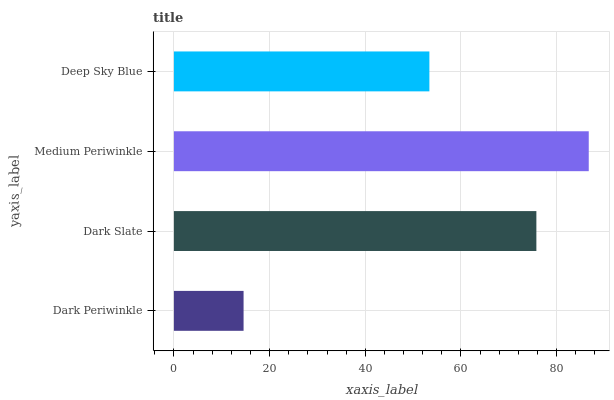Is Dark Periwinkle the minimum?
Answer yes or no. Yes. Is Medium Periwinkle the maximum?
Answer yes or no. Yes. Is Dark Slate the minimum?
Answer yes or no. No. Is Dark Slate the maximum?
Answer yes or no. No. Is Dark Slate greater than Dark Periwinkle?
Answer yes or no. Yes. Is Dark Periwinkle less than Dark Slate?
Answer yes or no. Yes. Is Dark Periwinkle greater than Dark Slate?
Answer yes or no. No. Is Dark Slate less than Dark Periwinkle?
Answer yes or no. No. Is Dark Slate the high median?
Answer yes or no. Yes. Is Deep Sky Blue the low median?
Answer yes or no. Yes. Is Medium Periwinkle the high median?
Answer yes or no. No. Is Medium Periwinkle the low median?
Answer yes or no. No. 